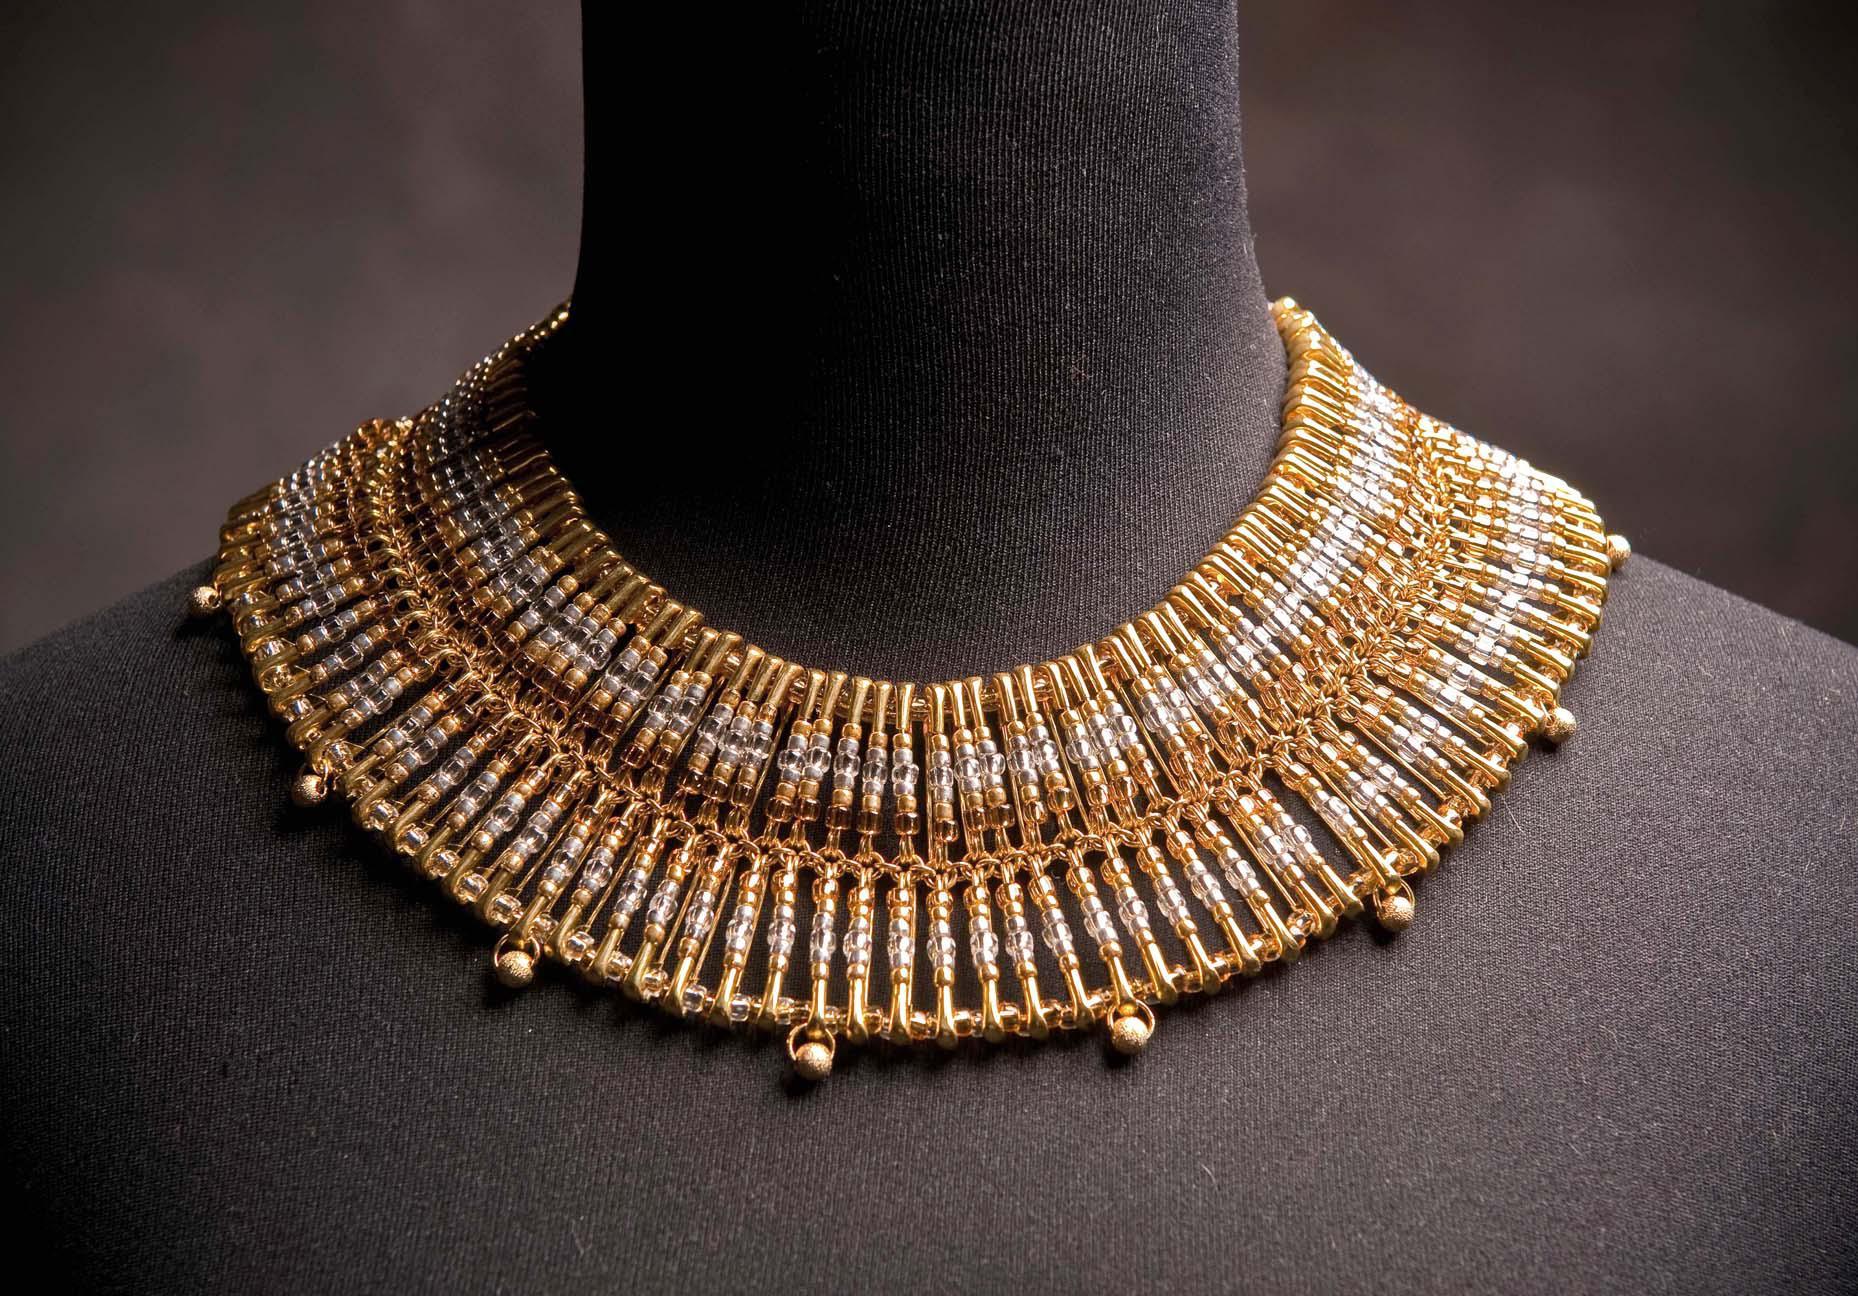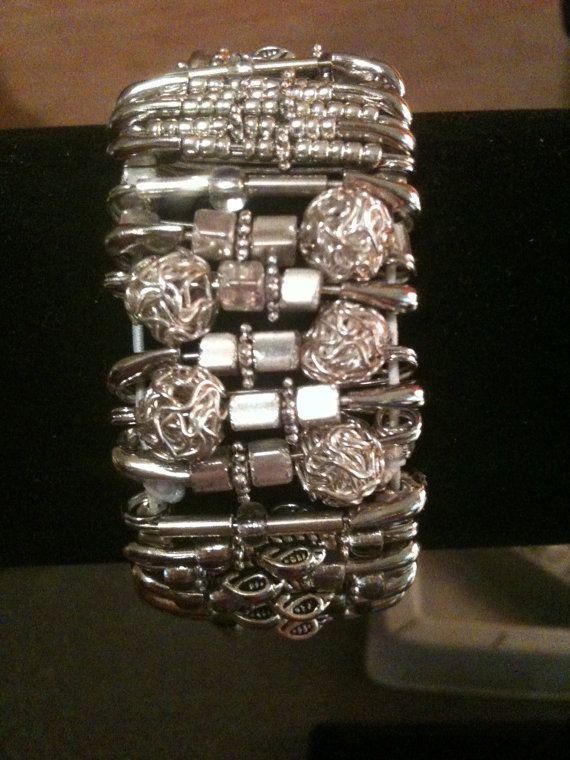The first image is the image on the left, the second image is the image on the right. Assess this claim about the two images: "A bracelet is lying on a surface in each of the images.". Correct or not? Answer yes or no. No. The first image is the image on the left, the second image is the image on the right. Considering the images on both sides, is "One image shows a safety pin necklace on a black display, and the other image shows a bracelet made with silver safety pins." valid? Answer yes or no. Yes. 